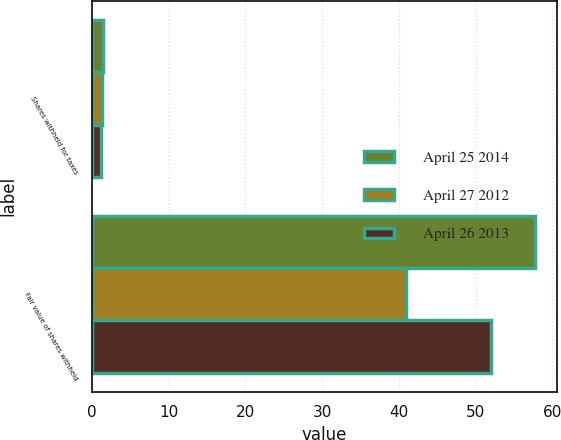Convert chart. <chart><loc_0><loc_0><loc_500><loc_500><stacked_bar_chart><ecel><fcel>Shares withheld for taxes<fcel>Fair value of shares withheld<nl><fcel>April 25 2014<fcel>1.5<fcel>57.7<nl><fcel>April 27 2012<fcel>1.3<fcel>40.9<nl><fcel>April 26 2013<fcel>1.2<fcel>52<nl></chart> 